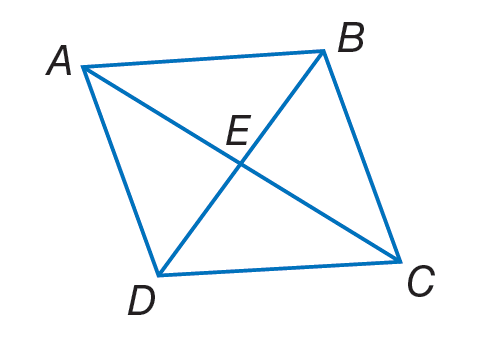Answer the mathemtical geometry problem and directly provide the correct option letter.
Question: A B C D is a rhombus. If E B = 9, A B = 12 and m \angle A B D = 55. Find m \angle A C B.
Choices: A: 9 B: 12 C: 21 D: 35 D 